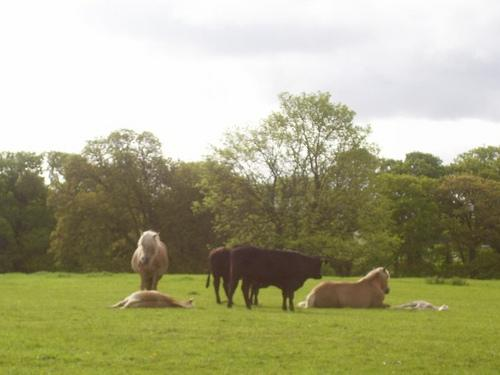Using comma-separated phrases, describe key components of the scene and their interactions. Horses and cows in field, some horses laying, others standing, cows standing, surrounded by trees, under bright sky. Describe what the horses are doing in the image and provide extra information about their color and surroundings. Some horses are laying and standing in a green field alongside black cows, framed by tall trees and a bright sky. What are the main animals in the picture? Explain their actions and describe the environment. Horses and cows, some horses standing and some laying, the cows are standing, in a lush grassy field with tall trees and a bright sky. Provide a compact and expressive description of the image, capturing the overall ambiance. A serene countryside scene with horses and cows grazing in a lush field under a vivid, cloud-specked sky. Describe the image with a focus on the vegetation and weather conditions. A scene with short grass, tall trees, and a bright, cloudy sky; horses and cows are grazing together in the vibrant field. Mention the details about the horses, cows, trees, and sky in the image. Several horses lay and stand near standing cows in a field, framed by tall trees and a bright, cloud-filled sky. Write a picturesque description of the image that captures the emotions and atmosphere. Under a brilliant sky dappled with clouds, horses and cows graze tranquilly in a lush pasture enclosed by lofty trees. Provide a brief summary of the image focusing on the animals and their actions. Horses and cows in a field, with some horses laying and others standing, while cows are standing and appear black. Describe the scene taking into consideration the animals and their surroundings. Horses and cows enjoying a lush grassy field, with tall trees lining the edge, under a bright sky filled with clouds. Provide a narrative-style description of the image that includes the animals and the environment. In a peaceful meadow under a brilliant, cloud-streaked sky, horses and cows stand and rest amid the lush, green grass and tall trees. 